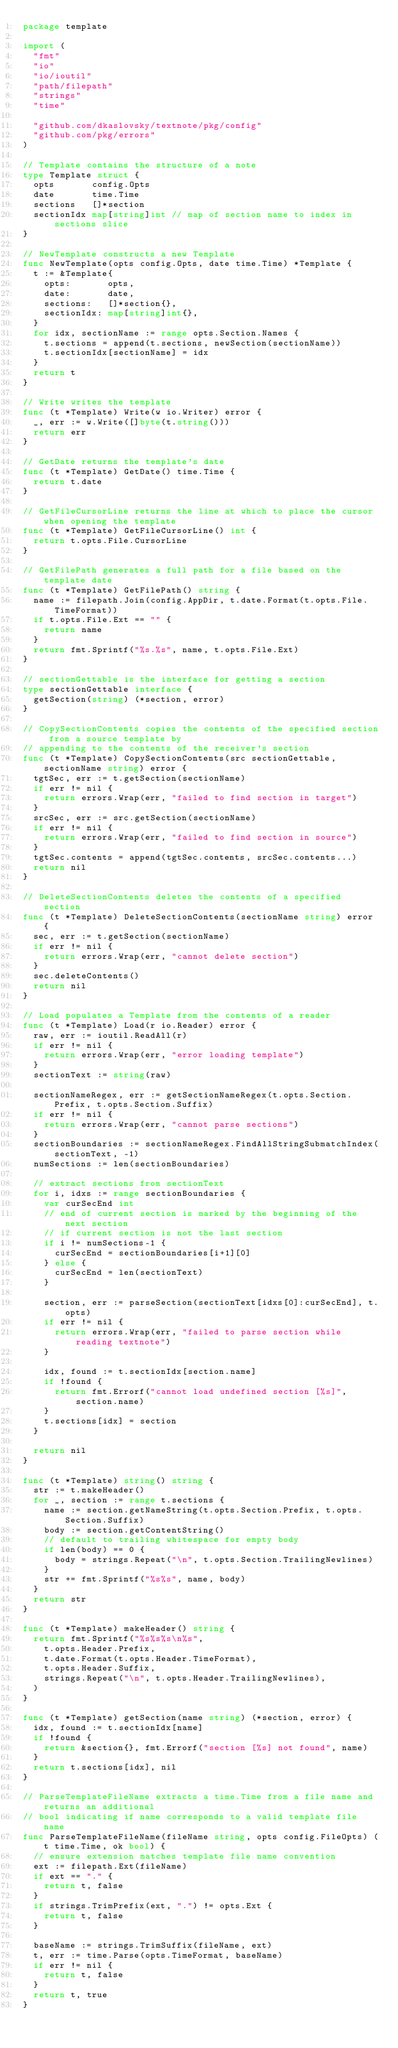<code> <loc_0><loc_0><loc_500><loc_500><_Go_>package template

import (
	"fmt"
	"io"
	"io/ioutil"
	"path/filepath"
	"strings"
	"time"

	"github.com/dkaslovsky/textnote/pkg/config"
	"github.com/pkg/errors"
)

// Template contains the structure of a note
type Template struct {
	opts       config.Opts
	date       time.Time
	sections   []*section
	sectionIdx map[string]int // map of section name to index in sections slice
}

// NewTemplate constructs a new Template
func NewTemplate(opts config.Opts, date time.Time) *Template {
	t := &Template{
		opts:       opts,
		date:       date,
		sections:   []*section{},
		sectionIdx: map[string]int{},
	}
	for idx, sectionName := range opts.Section.Names {
		t.sections = append(t.sections, newSection(sectionName))
		t.sectionIdx[sectionName] = idx
	}
	return t
}

// Write writes the template
func (t *Template) Write(w io.Writer) error {
	_, err := w.Write([]byte(t.string()))
	return err
}

// GetDate returns the template's date
func (t *Template) GetDate() time.Time {
	return t.date
}

// GetFileCursorLine returns the line at which to place the cursor when opening the template
func (t *Template) GetFileCursorLine() int {
	return t.opts.File.CursorLine
}

// GetFilePath generates a full path for a file based on the template date
func (t *Template) GetFilePath() string {
	name := filepath.Join(config.AppDir, t.date.Format(t.opts.File.TimeFormat))
	if t.opts.File.Ext == "" {
		return name
	}
	return fmt.Sprintf("%s.%s", name, t.opts.File.Ext)
}

// sectionGettable is the interface for getting a section
type sectionGettable interface {
	getSection(string) (*section, error)
}

// CopySectionContents copies the contents of the specified section from a source template by
// appending to the contents of the receiver's section
func (t *Template) CopySectionContents(src sectionGettable, sectionName string) error {
	tgtSec, err := t.getSection(sectionName)
	if err != nil {
		return errors.Wrap(err, "failed to find section in target")
	}
	srcSec, err := src.getSection(sectionName)
	if err != nil {
		return errors.Wrap(err, "failed to find section in source")
	}
	tgtSec.contents = append(tgtSec.contents, srcSec.contents...)
	return nil
}

// DeleteSectionContents deletes the contents of a specified section
func (t *Template) DeleteSectionContents(sectionName string) error {
	sec, err := t.getSection(sectionName)
	if err != nil {
		return errors.Wrap(err, "cannot delete section")
	}
	sec.deleteContents()
	return nil
}

// Load populates a Template from the contents of a reader
func (t *Template) Load(r io.Reader) error {
	raw, err := ioutil.ReadAll(r)
	if err != nil {
		return errors.Wrap(err, "error loading template")
	}
	sectionText := string(raw)

	sectionNameRegex, err := getSectionNameRegex(t.opts.Section.Prefix, t.opts.Section.Suffix)
	if err != nil {
		return errors.Wrap(err, "cannot parse sections")
	}
	sectionBoundaries := sectionNameRegex.FindAllStringSubmatchIndex(sectionText, -1)
	numSections := len(sectionBoundaries)

	// extract sections from sectionText
	for i, idxs := range sectionBoundaries {
		var curSecEnd int
		// end of current section is marked by the beginning of the next section
		// if current section is not the last section
		if i != numSections-1 {
			curSecEnd = sectionBoundaries[i+1][0]
		} else {
			curSecEnd = len(sectionText)
		}

		section, err := parseSection(sectionText[idxs[0]:curSecEnd], t.opts)
		if err != nil {
			return errors.Wrap(err, "failed to parse section while reading textnote")
		}

		idx, found := t.sectionIdx[section.name]
		if !found {
			return fmt.Errorf("cannot load undefined section [%s]", section.name)
		}
		t.sections[idx] = section
	}

	return nil
}

func (t *Template) string() string {
	str := t.makeHeader()
	for _, section := range t.sections {
		name := section.getNameString(t.opts.Section.Prefix, t.opts.Section.Suffix)
		body := section.getContentString()
		// default to trailing whitespace for empty body
		if len(body) == 0 {
			body = strings.Repeat("\n", t.opts.Section.TrailingNewlines)
		}
		str += fmt.Sprintf("%s%s", name, body)
	}
	return str
}

func (t *Template) makeHeader() string {
	return fmt.Sprintf("%s%s%s\n%s",
		t.opts.Header.Prefix,
		t.date.Format(t.opts.Header.TimeFormat),
		t.opts.Header.Suffix,
		strings.Repeat("\n", t.opts.Header.TrailingNewlines),
	)
}

func (t *Template) getSection(name string) (*section, error) {
	idx, found := t.sectionIdx[name]
	if !found {
		return &section{}, fmt.Errorf("section [%s] not found", name)
	}
	return t.sections[idx], nil
}

// ParseTemplateFileName extracts a time.Time from a file name and returns an additional
// bool indicating if name corresponds to a valid template file name
func ParseTemplateFileName(fileName string, opts config.FileOpts) (t time.Time, ok bool) {
	// ensure extension matches template file name convention
	ext := filepath.Ext(fileName)
	if ext == "." {
		return t, false
	}
	if strings.TrimPrefix(ext, ".") != opts.Ext {
		return t, false
	}

	baseName := strings.TrimSuffix(fileName, ext)
	t, err := time.Parse(opts.TimeFormat, baseName)
	if err != nil {
		return t, false
	}
	return t, true
}
</code> 